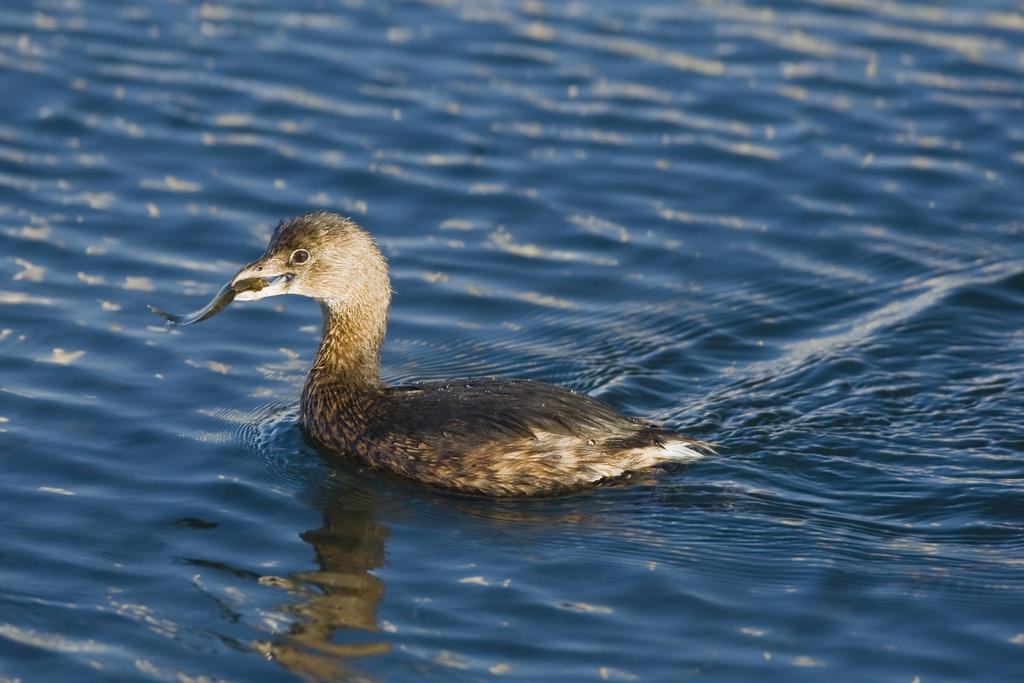What type of animal can be seen in the image? There is a bird in the image. What colors are present on the bird? The bird is in brown and cream color. Where is the bird located in the image? The bird is in the water. What type of brass instrument is the bird playing in the image? There is no brass instrument present in the image; it features a bird in the water. How many fingers does the bird have in the image? Birds do not have fingers, so this detail cannot be observed in the image. 